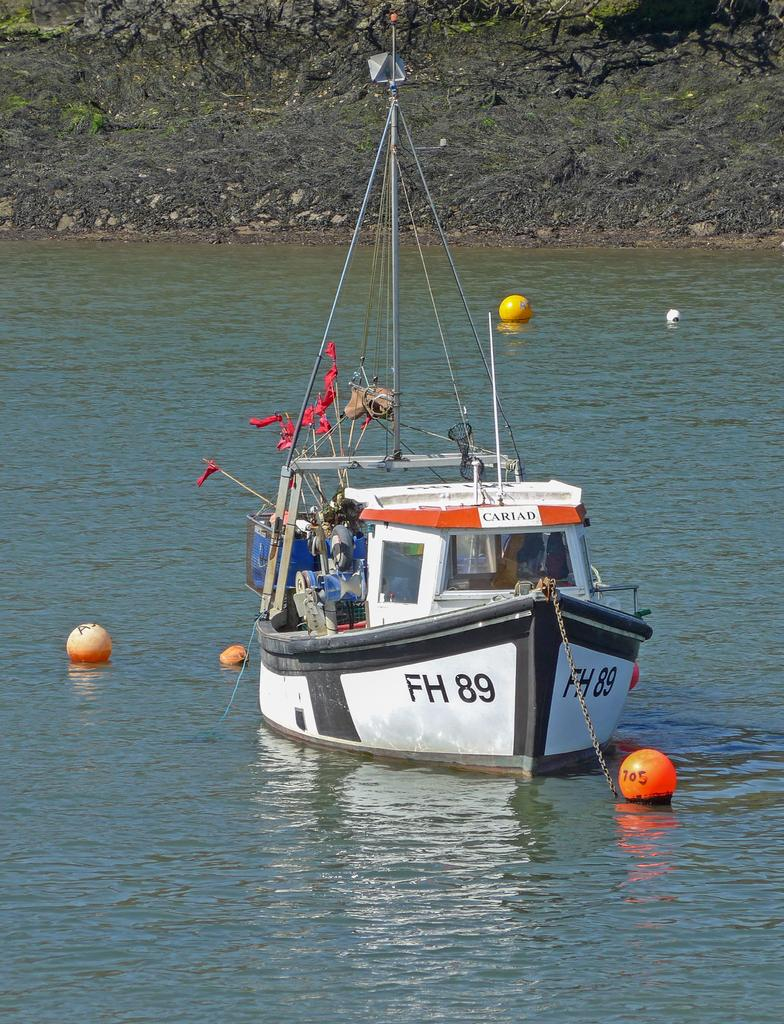What is the main subject in the center of the image? There is a ship in the center of the image. What can be seen flying in the image? There are flags in the image. What type of objects are present in the image besides the ship and flags? There are balls in the image. What is visible at the bottom of the image? There is water at the bottom of the image. What can be seen in the background of the image? There is a hill in the background of the image. What type of apparel is the ship wearing in the image? Ships do not wear apparel; the question is not applicable to the image. What is the ship thinking while it's in the water? Ships do not have thoughts; the question is not applicable to the image. 